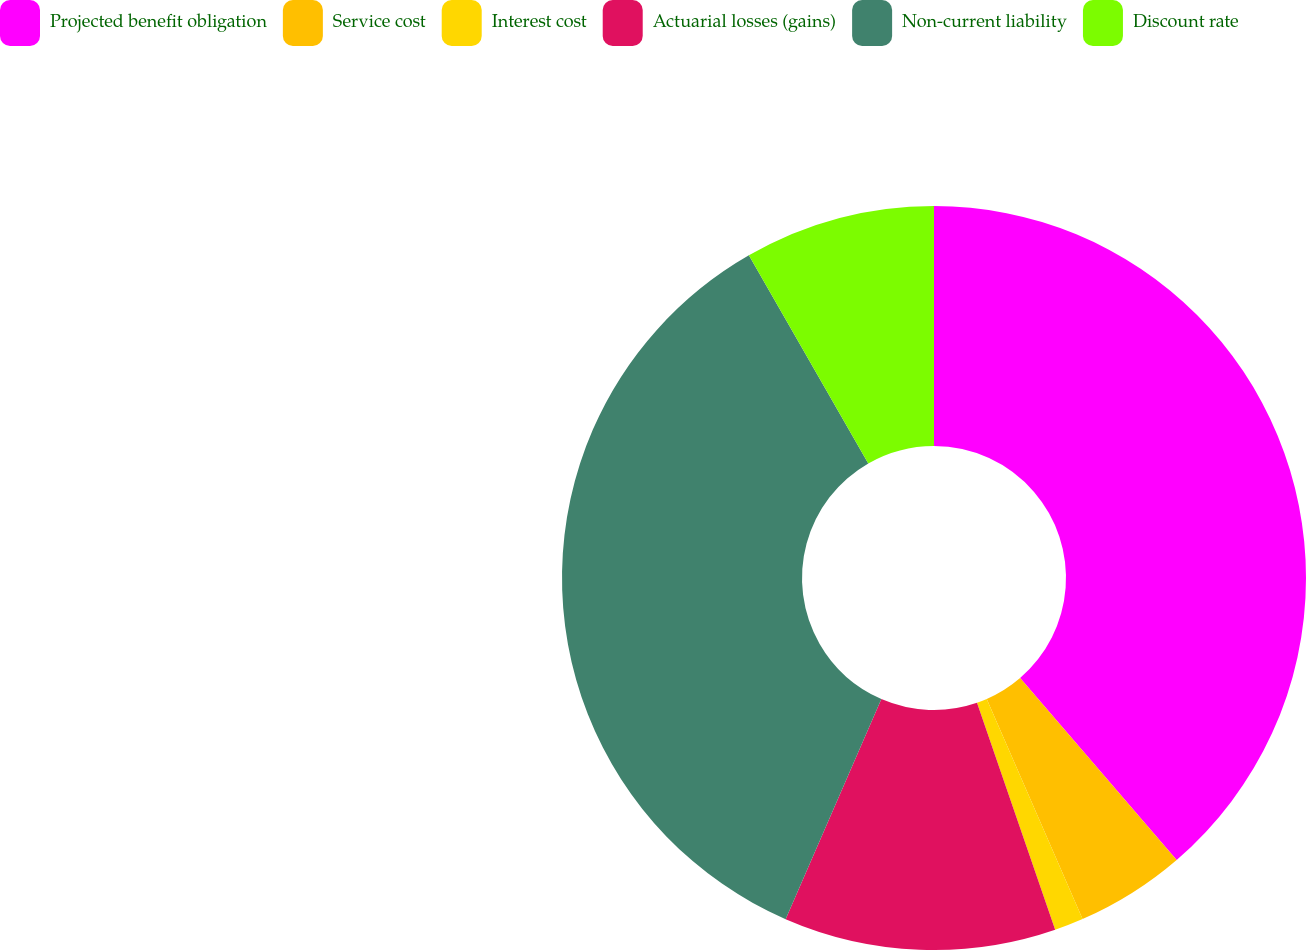Convert chart. <chart><loc_0><loc_0><loc_500><loc_500><pie_chart><fcel>Projected benefit obligation<fcel>Service cost<fcel>Interest cost<fcel>Actuarial losses (gains)<fcel>Non-current liability<fcel>Discount rate<nl><fcel>38.69%<fcel>4.77%<fcel>1.26%<fcel>11.81%<fcel>35.18%<fcel>8.29%<nl></chart> 